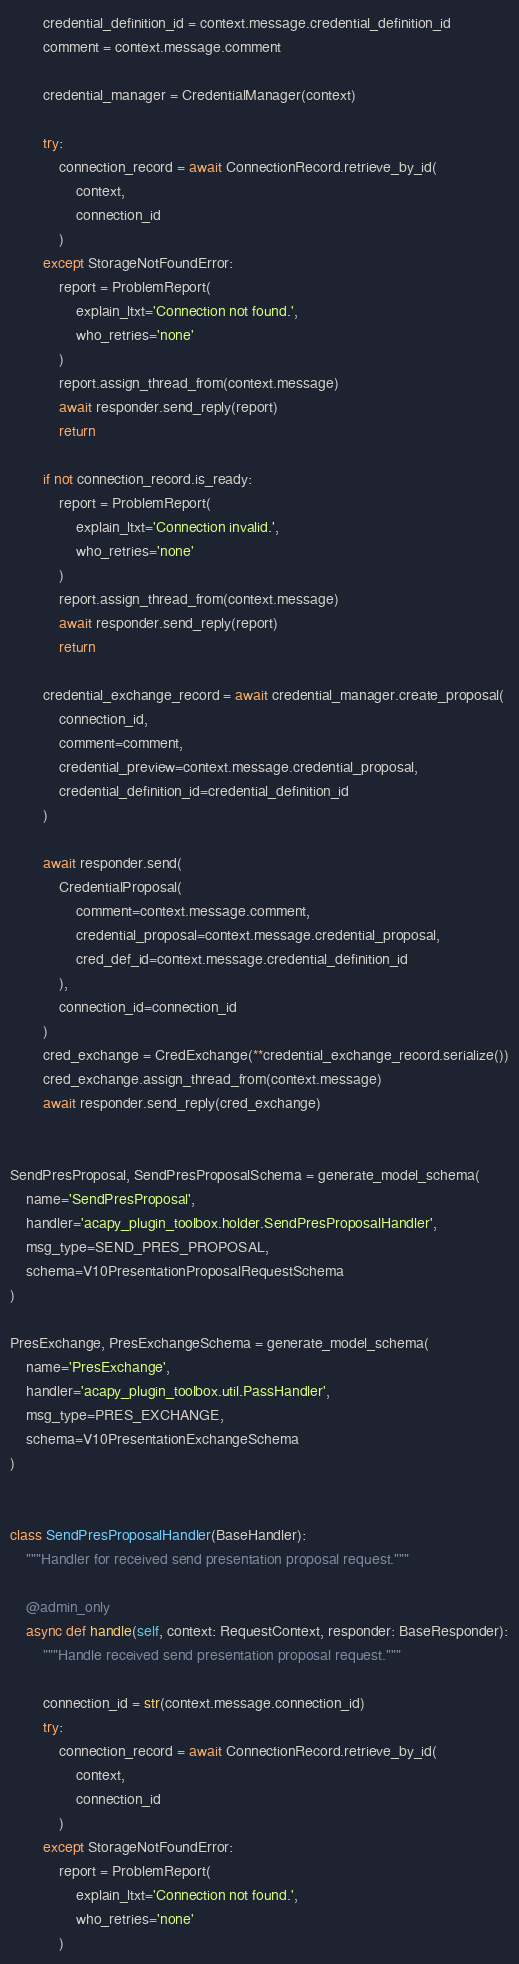Convert code to text. <code><loc_0><loc_0><loc_500><loc_500><_Python_>        credential_definition_id = context.message.credential_definition_id
        comment = context.message.comment

        credential_manager = CredentialManager(context)

        try:
            connection_record = await ConnectionRecord.retrieve_by_id(
                context,
                connection_id
            )
        except StorageNotFoundError:
            report = ProblemReport(
                explain_ltxt='Connection not found.',
                who_retries='none'
            )
            report.assign_thread_from(context.message)
            await responder.send_reply(report)
            return

        if not connection_record.is_ready:
            report = ProblemReport(
                explain_ltxt='Connection invalid.',
                who_retries='none'
            )
            report.assign_thread_from(context.message)
            await responder.send_reply(report)
            return

        credential_exchange_record = await credential_manager.create_proposal(
            connection_id,
            comment=comment,
            credential_preview=context.message.credential_proposal,
            credential_definition_id=credential_definition_id
        )

        await responder.send(
            CredentialProposal(
                comment=context.message.comment,
                credential_proposal=context.message.credential_proposal,
                cred_def_id=context.message.credential_definition_id
            ),
            connection_id=connection_id
        )
        cred_exchange = CredExchange(**credential_exchange_record.serialize())
        cred_exchange.assign_thread_from(context.message)
        await responder.send_reply(cred_exchange)


SendPresProposal, SendPresProposalSchema = generate_model_schema(
    name='SendPresProposal',
    handler='acapy_plugin_toolbox.holder.SendPresProposalHandler',
    msg_type=SEND_PRES_PROPOSAL,
    schema=V10PresentationProposalRequestSchema
)

PresExchange, PresExchangeSchema = generate_model_schema(
    name='PresExchange',
    handler='acapy_plugin_toolbox.util.PassHandler',
    msg_type=PRES_EXCHANGE,
    schema=V10PresentationExchangeSchema
)


class SendPresProposalHandler(BaseHandler):
    """Handler for received send presentation proposal request."""

    @admin_only
    async def handle(self, context: RequestContext, responder: BaseResponder):
        """Handle received send presentation proposal request."""

        connection_id = str(context.message.connection_id)
        try:
            connection_record = await ConnectionRecord.retrieve_by_id(
                context,
                connection_id
            )
        except StorageNotFoundError:
            report = ProblemReport(
                explain_ltxt='Connection not found.',
                who_retries='none'
            )</code> 